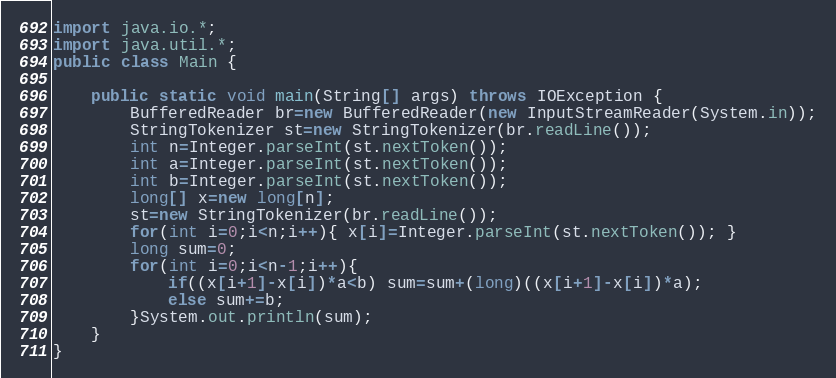Convert code to text. <code><loc_0><loc_0><loc_500><loc_500><_Java_>import java.io.*;
import java.util.*;
public class Main {
    
    public static void main(String[] args) throws IOException {
        BufferedReader br=new BufferedReader(new InputStreamReader(System.in));
        StringTokenizer st=new StringTokenizer(br.readLine());
        int n=Integer.parseInt(st.nextToken());
        int a=Integer.parseInt(st.nextToken());
        int b=Integer.parseInt(st.nextToken());
        long[] x=new long[n];
        st=new StringTokenizer(br.readLine());
        for(int i=0;i<n;i++){ x[i]=Integer.parseInt(st.nextToken()); }
        long sum=0;
        for(int i=0;i<n-1;i++){
            if((x[i+1]-x[i])*a<b) sum=sum+(long)((x[i+1]-x[i])*a);
            else sum+=b;
        }System.out.println(sum);
    }
}</code> 